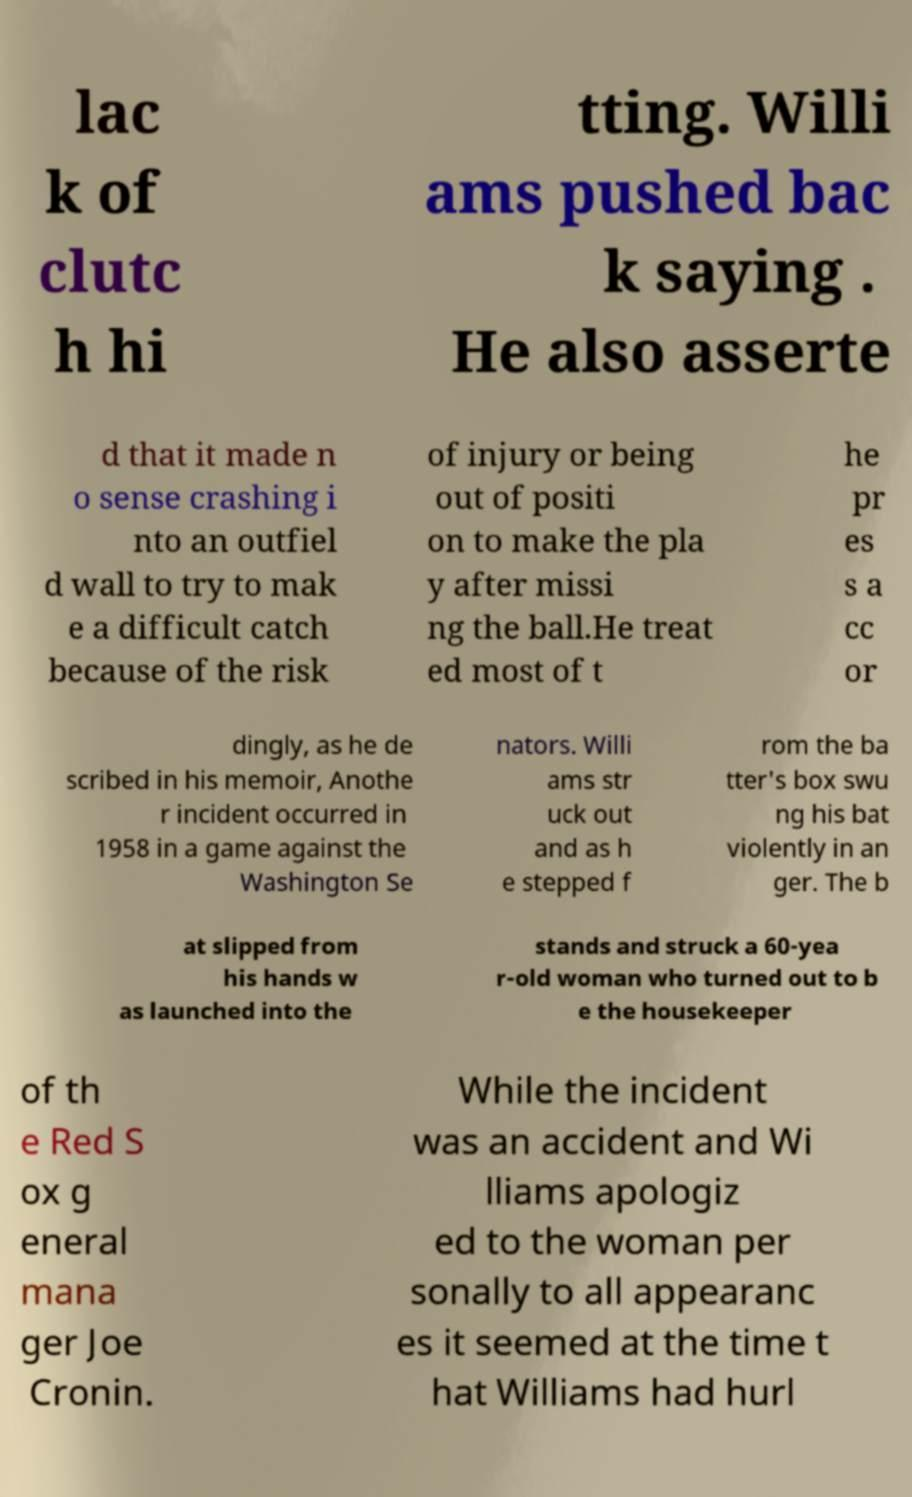Could you assist in decoding the text presented in this image and type it out clearly? lac k of clutc h hi tting. Willi ams pushed bac k saying . He also asserte d that it made n o sense crashing i nto an outfiel d wall to try to mak e a difficult catch because of the risk of injury or being out of positi on to make the pla y after missi ng the ball.He treat ed most of t he pr es s a cc or dingly, as he de scribed in his memoir, Anothe r incident occurred in 1958 in a game against the Washington Se nators. Willi ams str uck out and as h e stepped f rom the ba tter's box swu ng his bat violently in an ger. The b at slipped from his hands w as launched into the stands and struck a 60-yea r-old woman who turned out to b e the housekeeper of th e Red S ox g eneral mana ger Joe Cronin. While the incident was an accident and Wi lliams apologiz ed to the woman per sonally to all appearanc es it seemed at the time t hat Williams had hurl 